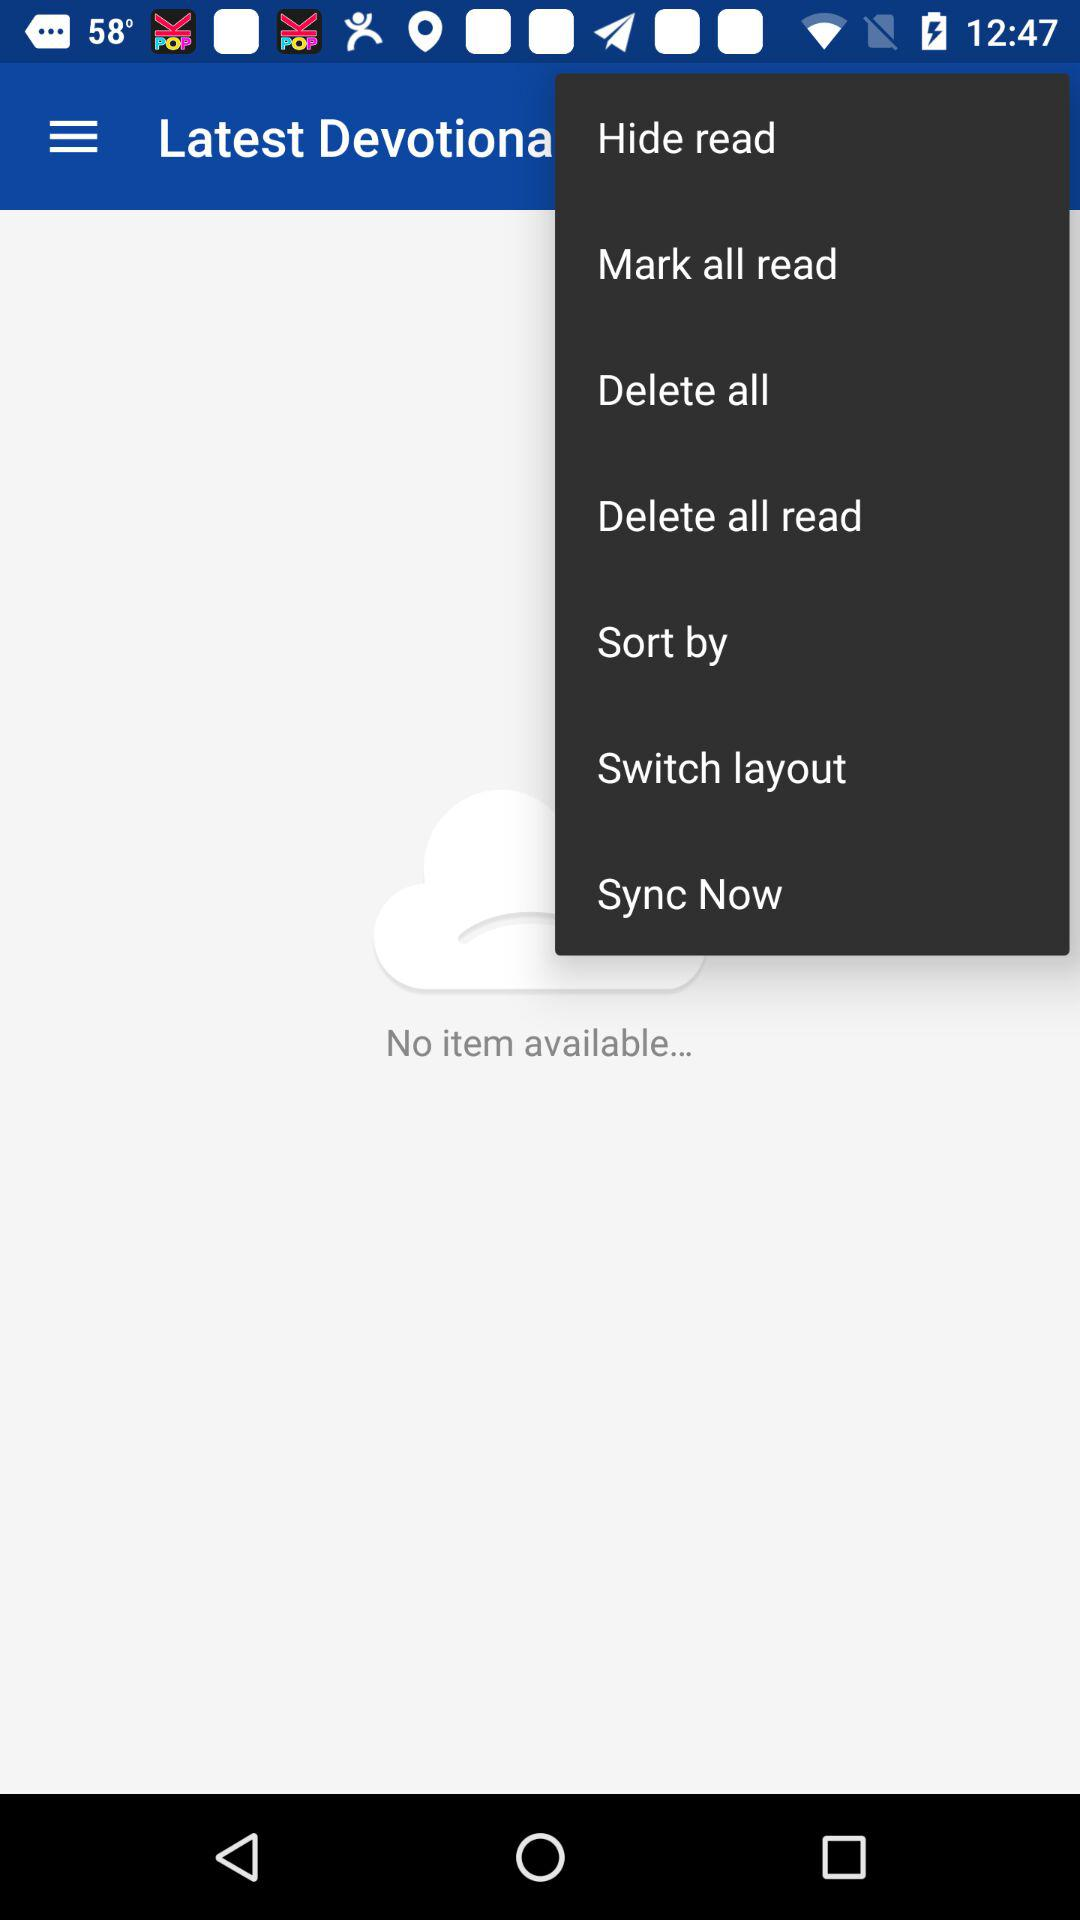How many items are available? There are no items available. 